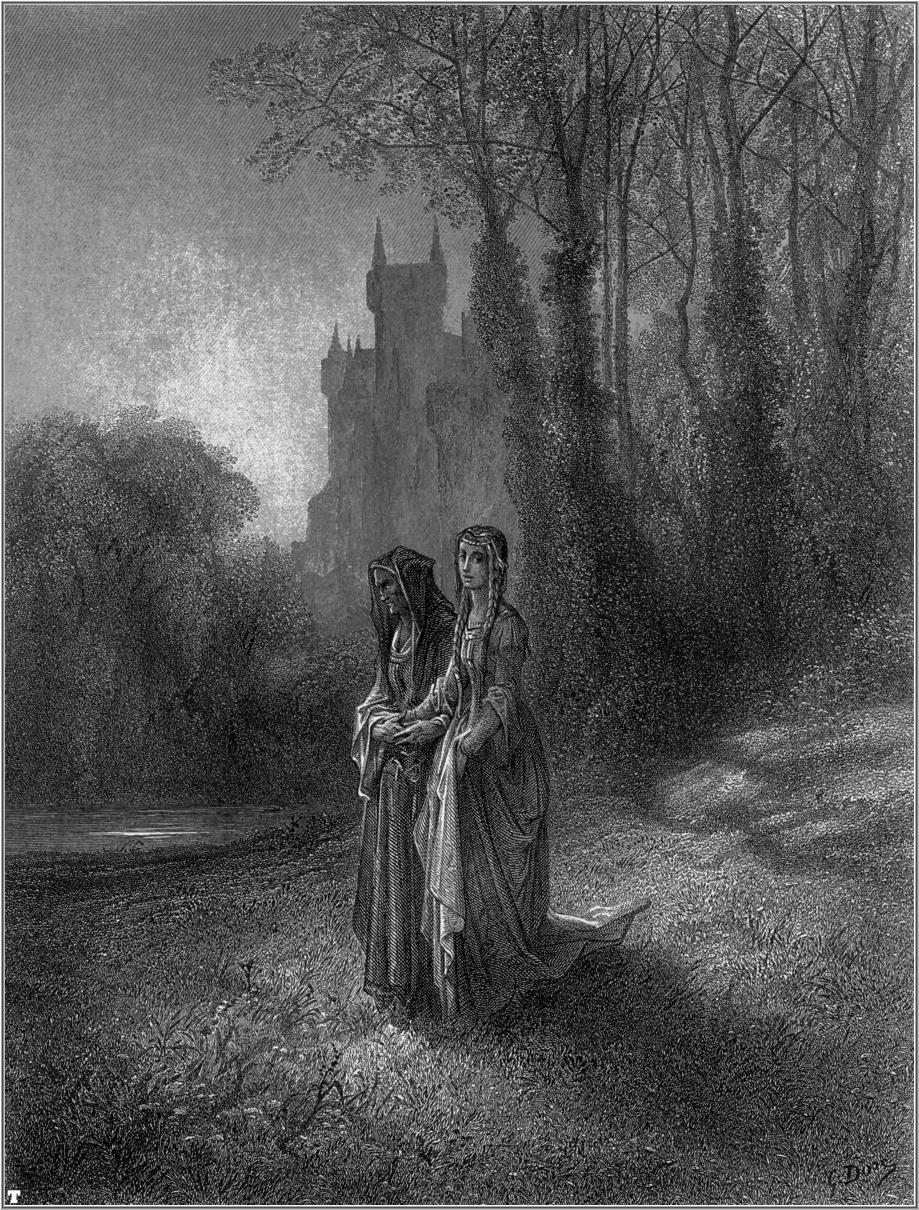In a realistic scenario, what are some possible reasons the women are walking in the forest? In a realistic scenario, the women might be out in the forest for several plausible reasons. They could be gathering medicinal herbs, mushrooms, or berries, which were common activities in historical and rural communities. Another possibility is that they are seeking a quiet place for contemplation or prayer, away from the confines of their daily lives. Given the presence of the castle, they might be exploring their domain, ensuring the safety and well-being of their lands. Additionally, it could simply be a leisurely walk, enjoying the beauty and serenity of nature, a routine they possibly cherish amid their structured lives in the castle. 